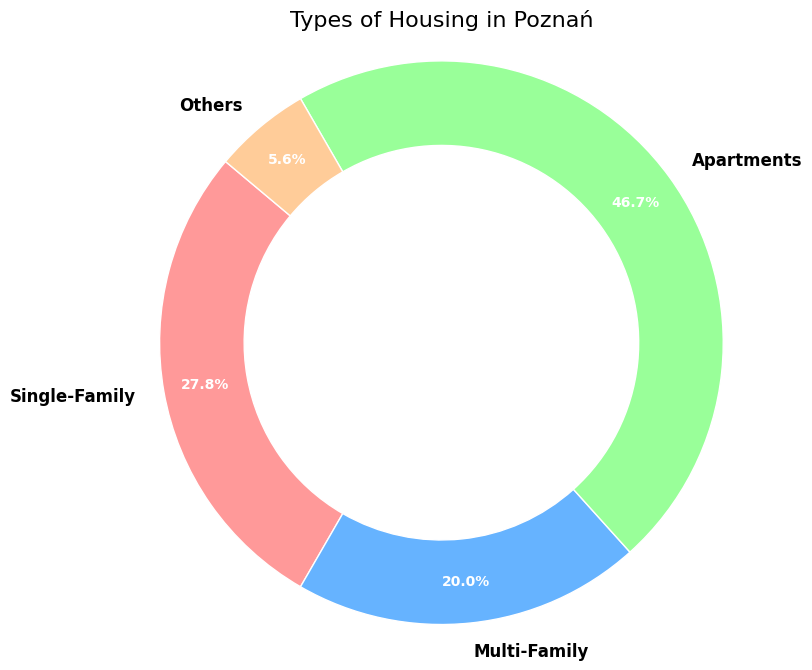Which housing type has the highest percentage in the figure? The figure shows that the 'Apartments' section has the largest portion. Referring to the percentage labels, the 'Apartments' type accounts for 47.7%.
Answer: Apartments Which housing type has the lowest count in the figure? The figure shows the smallest percentage for the 'Others' category, which is labeled as 5.7%, indicating it has the lowest count.
Answer: Others What is the percentage difference between Single-Family and Multi-Family housing types? The percentage for Single-Family is 29.8% and for Multi-Family is 21.4%. The difference is calculated as 29.8% - 21.4% = 8.4%.
Answer: 8.4% What is the combined percentage of Single-Family and Multi-Family housing types? The percentage for Single-Family is 29.8% and for Multi-Family is 21.4%. Adding these together, we get 29.8% + 21.4% = 51.2%.
Answer: 51.2% Which two housing types together make up more than half of the chart? Looking at the figure, 'Single-Family' and 'Apartments' percentages are 29.8% and 47.7%, respectively. Their combined total is 29.8% + 47.7% = 77.5%, which is more than half.
Answer: Single-Family and Apartments How many housing types occupy less than a quarter of the total each? The 'Multi-Family' and 'Others' categories show percentages of 21.4% and 5.7% respectively, both of which are less than 25%. So, there are 2 such types.
Answer: 2 What is the ratio of Apartments to Multi-Family housing counts? As per the data, Apartments have a count of 42000 and Multi-Family has 18000. The ratio is calculated as 42000 / 18000 = 2.33 (approximately).
Answer: 2.33 Which housing type shares the same color as the Multi-Family type? Visual inspection of the chart reveals that the color associated with 'Multi-Family' is blue. There is no other housing type sharing the same color.
Answer: None 